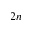Convert formula to latex. <formula><loc_0><loc_0><loc_500><loc_500>2 n</formula> 